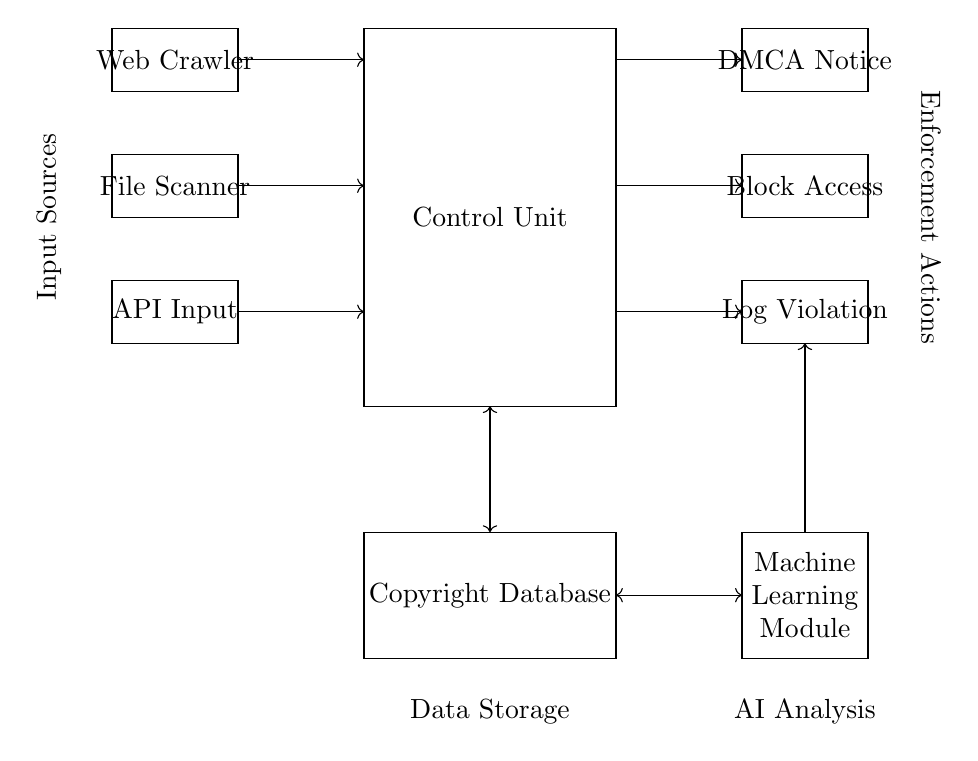What is the main component labeled in the circuit? The main component labeled is the "Control Unit," which serves as the central processing unit for the entire circuit. It's indicated by the rectangle drawn at coordinates (0,0) to (4,6).
Answer: Control Unit What is the purpose of the Web Crawler block? The Web Crawler block is responsible for scanning the internet for potential copyright infringement occurrences by searching websites for copyrighted materials. It is located at coordinates (-4,5) to (-2,6).
Answer: Copyright detection How many output actions are defined in the circuit? There are three output actions in the circuit: "DMCA Notice," "Block Access," and "Log Violation," which are represented by rectangles at coordinates (6,5) to (8,6), (6,3) to (8,4), and (6,1) to (8,2) respectively.
Answer: Three Which module analyzes the data stored in the Copyright Database? The Machine Learning Module analyzes the data stored in the Copyright Database. It is depicted by the rectangle drawn at (6,-2) to (8,-4), and it receives data from the control unit for processing.
Answer: Machine Learning Module What type of input sources are implemented in the circuit? The input sources implemented in the circuit include "Web Crawler," "File Scanner," and "API Input," which are responsible for supplying data into the control unit for processing. They are located at various vertical positions on the left side of the diagram.
Answer: Three types What does the bi-directional arrow between the Control Unit and the Copyright Database signify? The bi-directional arrow indicates that there is communication in both directions between the Control Unit and the Copyright Database, meaning the control unit can both access data from the database and send data to it for storage or updates.
Answer: Data communication How are the output actions linked to the control unit in the circuit? The output actions are linked to the control unit with unidirectional arrows pointing from the control unit to each of the output action blocks, indicating that the control unit sends signals to execute these actions based on its analysis of the input data.
Answer: Unidirectional connections 